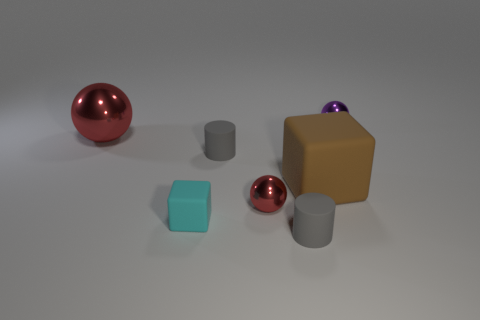How many other objects are the same shape as the small purple thing?
Offer a terse response. 2. What is the color of the small thing that is in front of the big cube and behind the tiny rubber cube?
Provide a short and direct response. Red. The small matte cube is what color?
Your answer should be very brief. Cyan. Is the cyan block made of the same material as the sphere that is behind the big red sphere?
Your response must be concise. No. There is a small cyan thing that is made of the same material as the large brown block; what shape is it?
Make the answer very short. Cube. There is a ball that is the same size as the brown rubber thing; what is its color?
Keep it short and to the point. Red. There is a red ball that is on the left side of the cyan matte cube; is its size the same as the tiny red shiny ball?
Provide a succinct answer. No. How many small cubes are there?
Offer a very short reply. 1. How many blocks are either tiny gray rubber objects or large red metallic things?
Give a very brief answer. 0. What number of cyan blocks are right of the gray cylinder that is behind the small red object?
Make the answer very short. 0. 